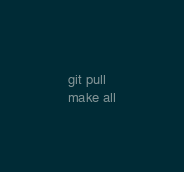Convert code to text. <code><loc_0><loc_0><loc_500><loc_500><_Bash_>
git pull
make all</code> 